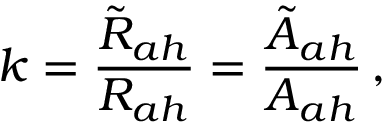Convert formula to latex. <formula><loc_0><loc_0><loc_500><loc_500>k = \frac { { \tilde { R } } _ { a h } } { R _ { a h } } = \frac { { \tilde { A } } _ { a h } } { A _ { a h } } \, ,</formula> 